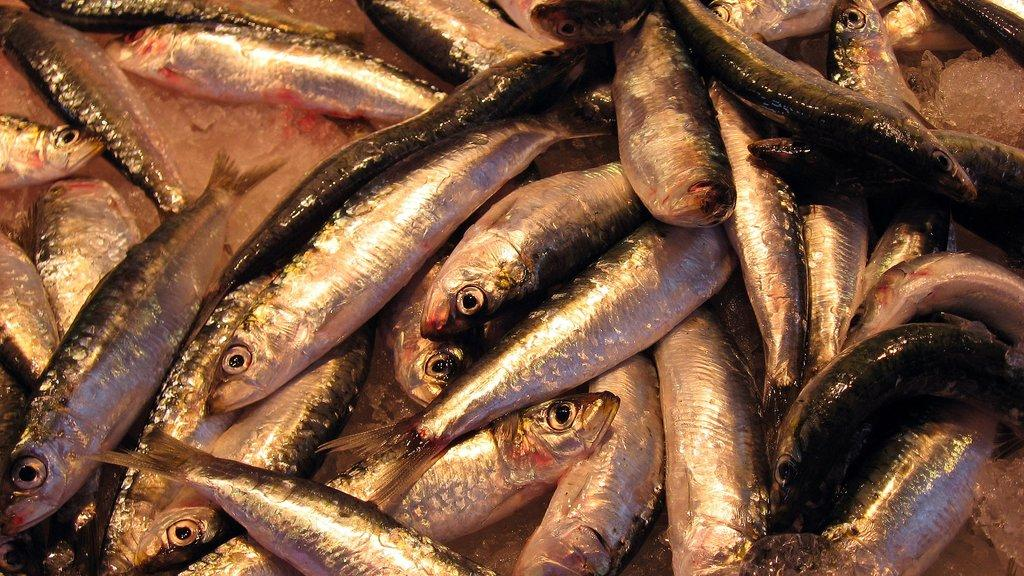What type of animals can be seen in the image? There are many fish in the image. How are the fish being stored or displayed? The fish are kept on ice. What type of motion can be observed in the fish in the image? The fish are not moving in the image, as they are kept on ice. Can you see a crow interacting with the fish in the image? There is no crow present in the image. 